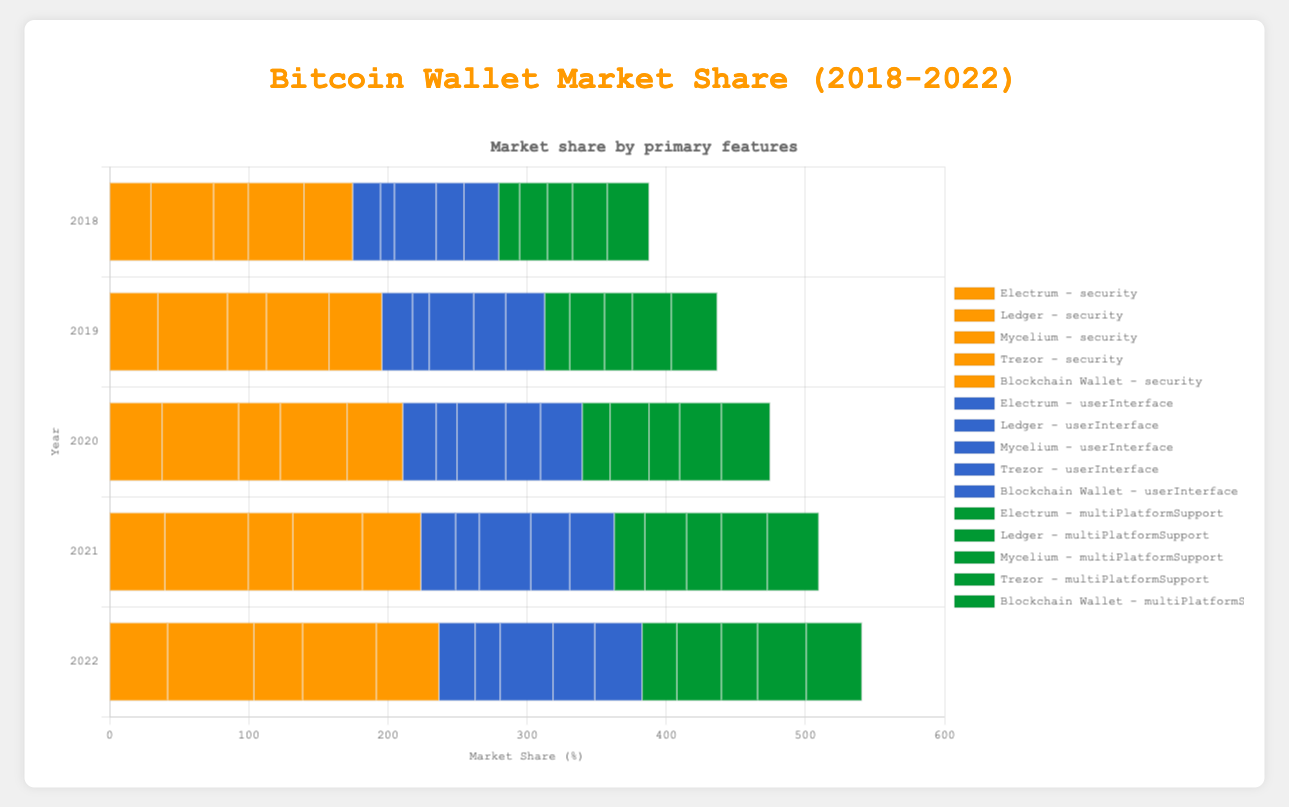What is the most significant feature for Ledger in 2022? In 2022, for Ledger, check the values for security (62), user interface (18), and multi-platform support (32). The largest value is 62 for security.
Answer: Security How much did the security market share increase for Electrum from 2018 to 2022? The security market share for Electrum in 2018 is 30, and in 2022 it is 42. The increase is 42 - 30 = 12.
Answer: 12 Which wallet had the highest user interface market share in 2020? For 2020, compare the user interface values: Electrum (24), Ledger (15), Mycelium (35), Trezor (25), Blockchain Wallet (30). Mycelium has the highest value (35).
Answer: Mycelium Which wallet had the largest increase in multi-platform support market share between 2018 and 2022? Calculate the increase for each wallet from 2018 to 2022: Electrum (25 - 15 = 10), Ledger (32 - 20 = 12), Mycelium (26 - 18 = 8), Trezor (35 - 25 = 10), Blockchain Wallet (40 - 30 = 10). Ledger has the largest increase (12).
Answer: Ledger What is the total market share for Trezor across all features in 2021? In 2021, add Trezor's market shares: security (50), user interface (28), and multi-platform support (33). Total is 50 + 28 + 33 = 111.
Answer: 111 Compared to 2018, which feature for Blockchain Wallet saw the smallest increase in market share by 2022? Compare the increases by feature: security (45 - 35 = 10), user interface (34 - 25 = 9), multi-platform support (40 - 30 = 10). The smallest increase is 9 for user interface.
Answer: User Interface Which feature had the overall greatest growth from 2018 to 2022 across all wallets? Sum the growth for each feature: 
- Security: Electrum (12), Ledger (17), Mycelium (10), Trezor (13), Blockchain Wallet (10). Total: 62
- User Interface: Electrum (6), Ledger (8), Mycelium (8), Trezor (10), Blockchain Wallet (9). Total: 41
- Multi-Platform Support: Electrum (10), Ledger (12), Mycelium (8), Trezor (10), Blockchain Wallet (10). Total: 50
The greatest growth is for Security with a total of 62.
Answer: Security Which wallet had a consistent increase in security features from 2018 to 2022 each year? Check for wallets where security values increase yearly: Electrum (yes: 30 -> 35 -> 38 -> 40 -> 42), Ledger (yes: 45 -> 50 -> 55 -> 60 -> 62), Mycelium (yes: 25 -> 28 -> 30 -> 32 -> 35), Trezor (yes: 40 -> 45 -> 48 -> 50 -> 53), Blockchain Wallet (yes: 35 -> 38 -> 40 -> 42 -> 45). All wallets had a consistent increase.
Answer: All wallets 